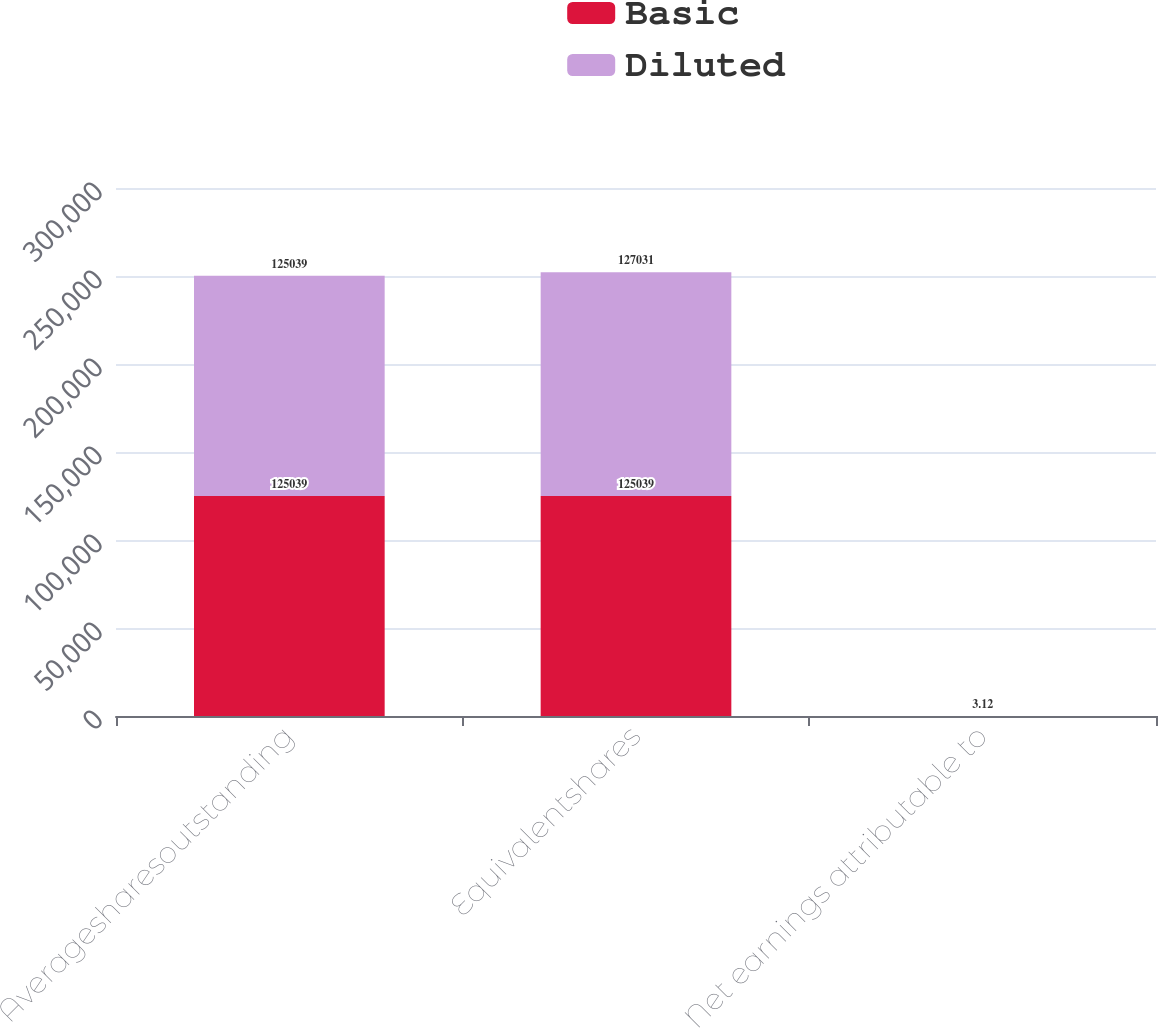Convert chart. <chart><loc_0><loc_0><loc_500><loc_500><stacked_bar_chart><ecel><fcel>Averagesharesoutstanding<fcel>Equivalentshares<fcel>Net earnings attributable to<nl><fcel>Basic<fcel>125039<fcel>125039<fcel>3.17<nl><fcel>Diluted<fcel>125039<fcel>127031<fcel>3.12<nl></chart> 